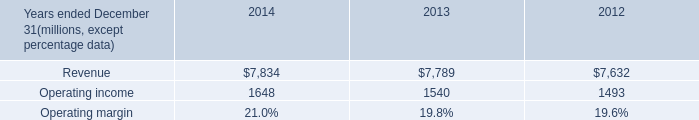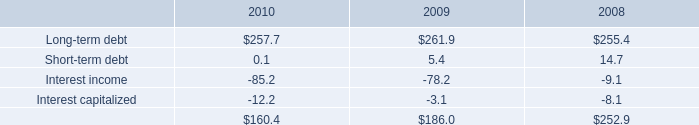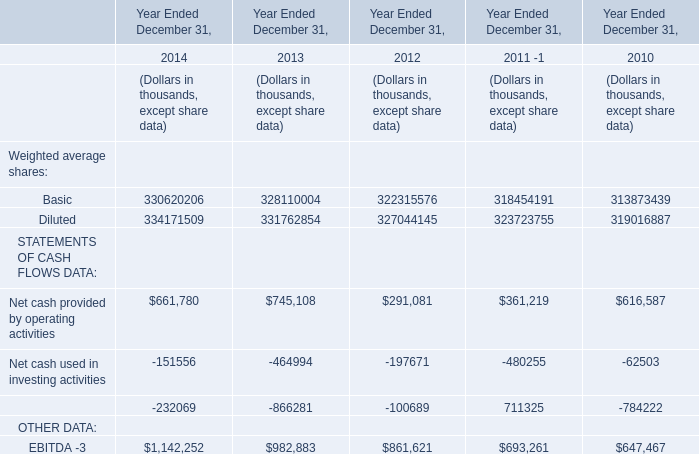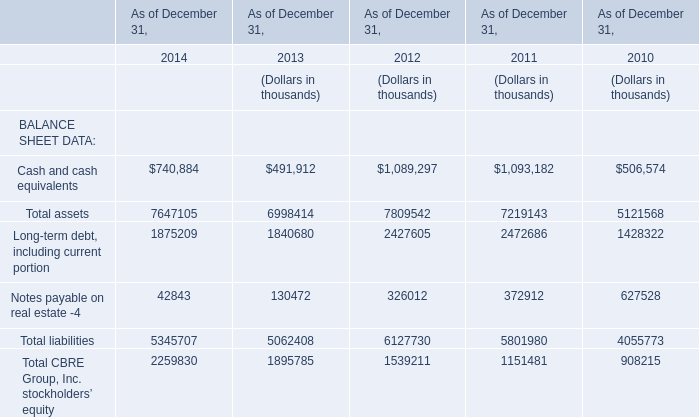What is the average value of Long-term debt and Cash and cash equivalents for BALANCE SHEET DATA in 2010? (in thousand) 
Computations: ((257.7 + 506574) / 2)
Answer: 253415.85. 